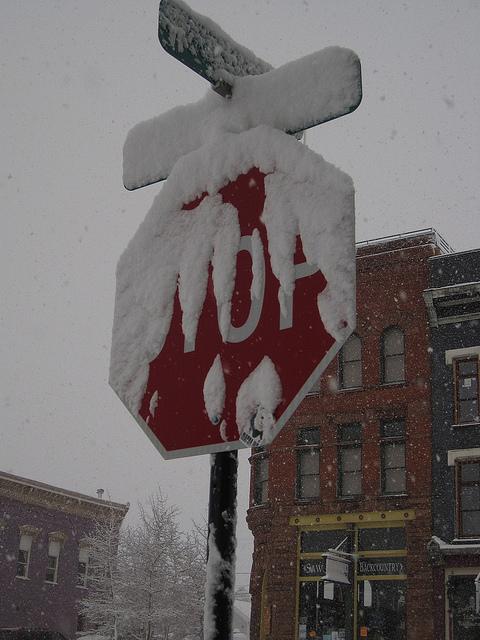Is it a sunny day?
Quick response, please. No. Is it snowing?
Keep it brief. Yes. Is it summer?
Concise answer only. No. What is on top of the sign?
Short answer required. Snow. Which sign is not covered in snow?
Give a very brief answer. Stop. What style of building is in the background?
Concise answer only. Brick. 